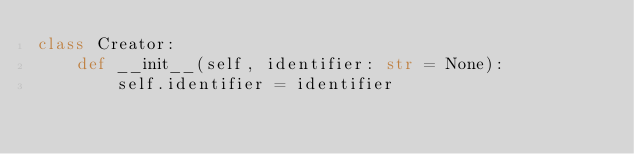Convert code to text. <code><loc_0><loc_0><loc_500><loc_500><_Python_>class Creator:
    def __init__(self, identifier: str = None):
        self.identifier = identifier
</code> 